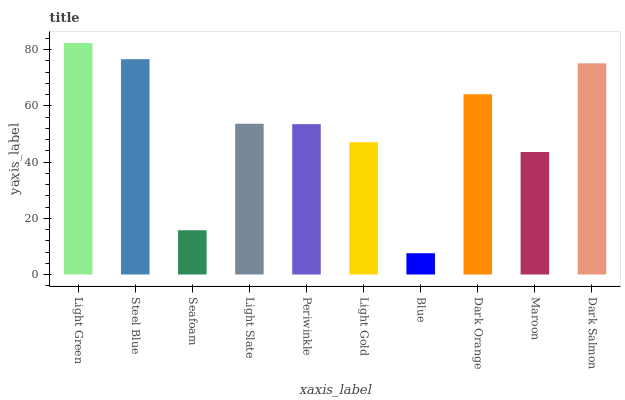Is Blue the minimum?
Answer yes or no. Yes. Is Light Green the maximum?
Answer yes or no. Yes. Is Steel Blue the minimum?
Answer yes or no. No. Is Steel Blue the maximum?
Answer yes or no. No. Is Light Green greater than Steel Blue?
Answer yes or no. Yes. Is Steel Blue less than Light Green?
Answer yes or no. Yes. Is Steel Blue greater than Light Green?
Answer yes or no. No. Is Light Green less than Steel Blue?
Answer yes or no. No. Is Light Slate the high median?
Answer yes or no. Yes. Is Periwinkle the low median?
Answer yes or no. Yes. Is Steel Blue the high median?
Answer yes or no. No. Is Dark Orange the low median?
Answer yes or no. No. 